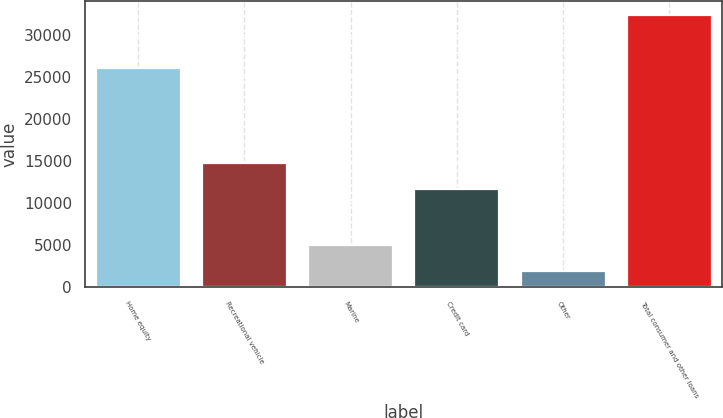<chart> <loc_0><loc_0><loc_500><loc_500><bar_chart><fcel>Home equity<fcel>Recreational vehicle<fcel>Marine<fcel>Credit card<fcel>Other<fcel>Total consumer and other loans<nl><fcel>26049<fcel>14757.8<fcel>4984.8<fcel>11714<fcel>1941<fcel>32379<nl></chart> 